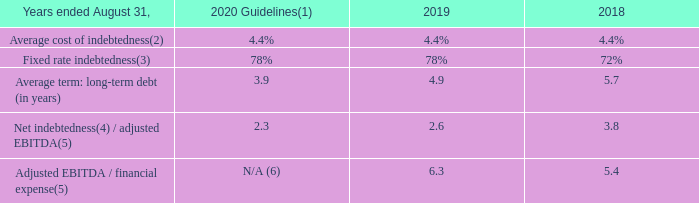8.1 CAPITAL STRUCTURE
The table below summarizes debt-related financial ratios over the last two fiscal years and the fiscal 2020 guidelines:
(1) Based on mid-range guidelines. (2) Excludes amortization of deferred transaction costs and commitment fees but includes the impact of interest rate swaps. Potential variations in the US LIBOR rates in fiscal 2020 have not been considered. (3) Taking into consideration the interest rate swaps in effect at the end of each fiscal year. (4) Net indebtedness is defined as the aggregate of bank indebtedness, balance due on business combinations and principal on long-term debt, less cash and cash equivalents. (5) Adjusted EBITDA and financial expense for fiscal year 2018 include only eight months of MetroCast operations. (6) Specific guidance on interest coverage cannot be provided given that financial expense guidance is not provided.
In fiscal 2019, the financial leverage ratio relating to net indebtedness over adjusted EBITDA has declined as a result of the sale of Cogeco Peer 1 on April 30, 2019 for a net cash consideration of $720 million and to a lesser extent growing adjusted EBITDA and a reduction in net indebtedness from generated free cash flow. In fiscal 2020, prior to the adoption of IFRS 16 Leases, the financial leverage ratio relating to net indebtedness over adjusted EBITDA should continue to decline as a result of growing adjusted EBITDA and a projected reduction in net indebtedness from generated free cash flow.
How many months of MetroCast operations are included in 2018? Eight months. How much was the net cash consideration in 2019? $720 million. What is the company's projection for EBITDA? Ebitda should continue to decline as a result of growing adjusted ebitda and a projected reduction in net indebtedness from generated free cash flow. What was the increase / (decrease) in the Average cost of indebtedness from 2019 to 2020?
Answer scale should be: percent. 4.4% - 4.4%
Answer: 0. What was the average Net indebtedness / adjusted EBITDA for Fiscal 2019 and 2020?
Answer scale should be: percent. (2.3 + 2.6) / 2
Answer: 2.45. What was the increase / (decrease) in the Average term: long-term debt (in years) from 2018 to 2019?
Answer scale should be: percent. 4.9 - 5.7
Answer: -0.8. 